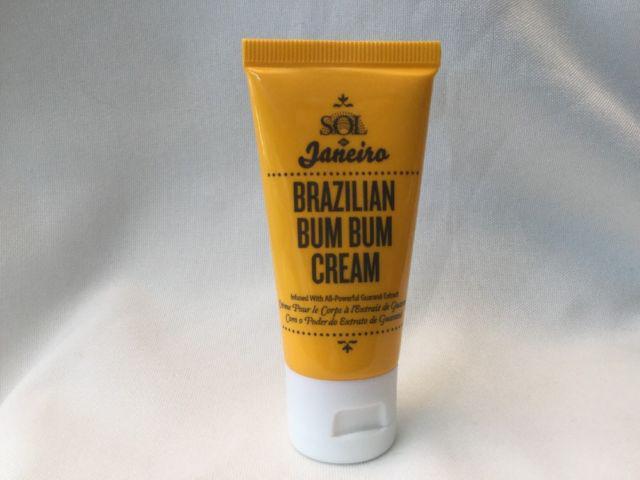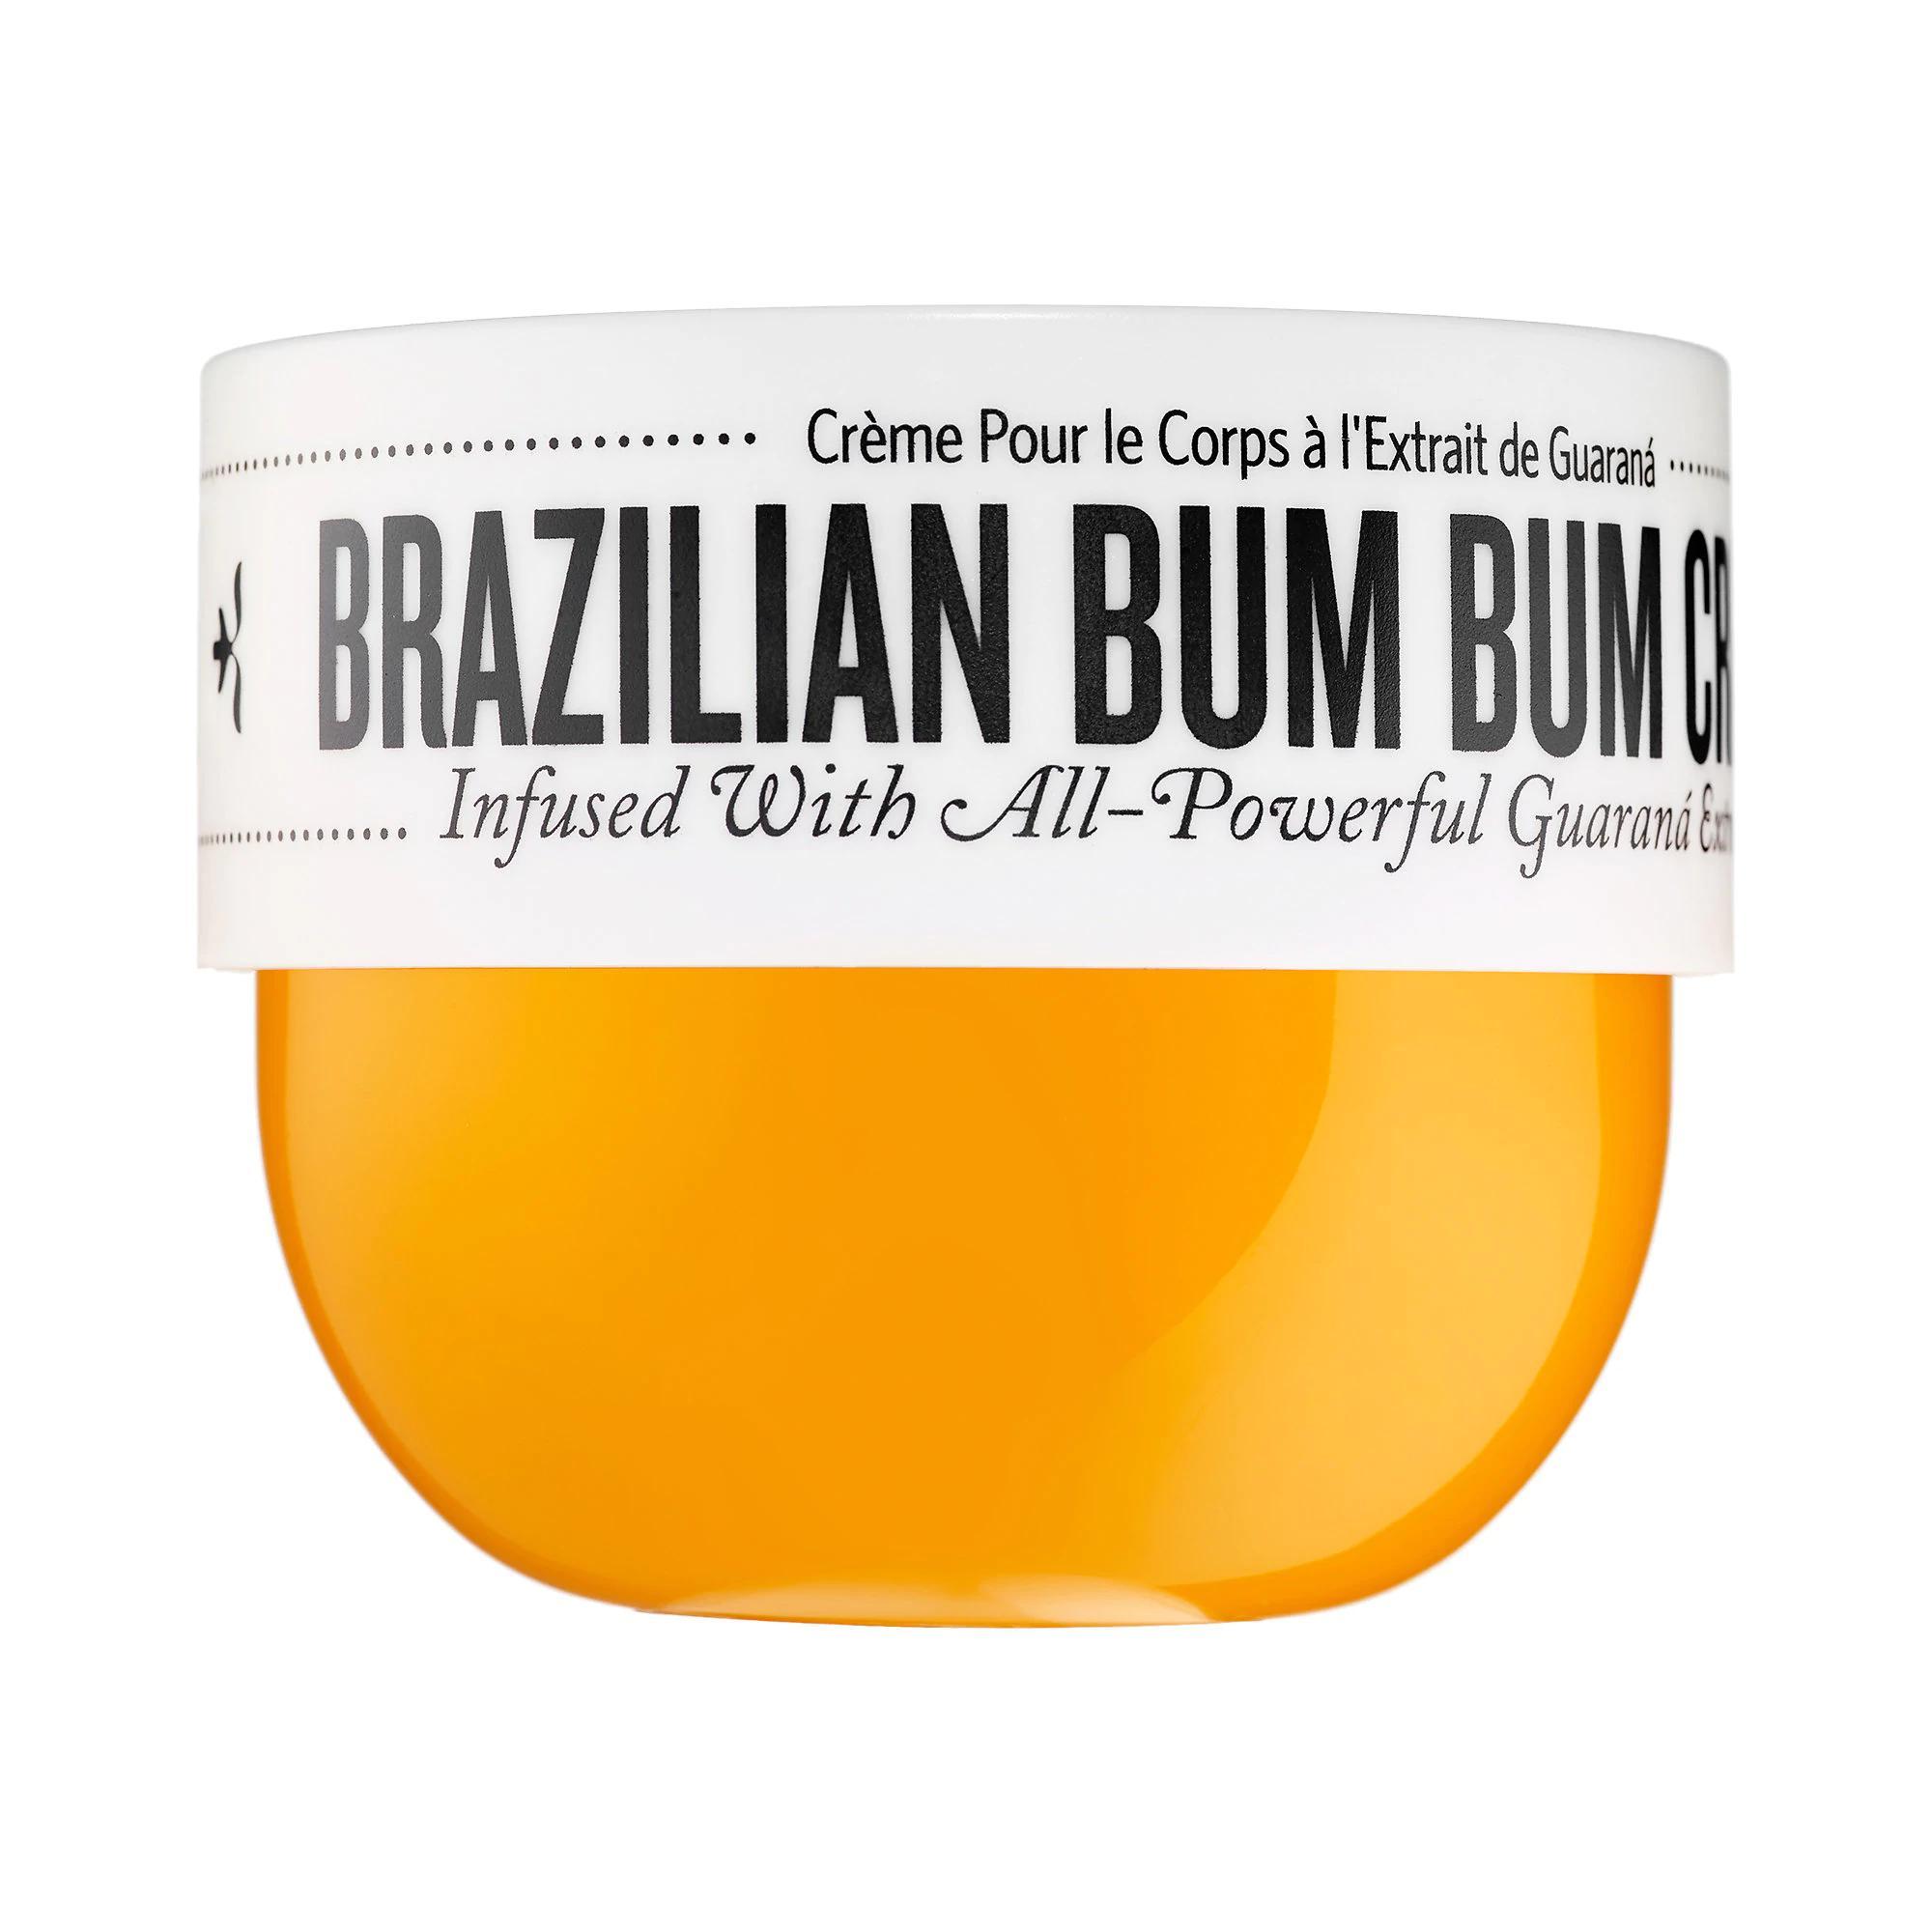The first image is the image on the left, the second image is the image on the right. Given the left and right images, does the statement "One of the images contains only a single orange squeeze tube with a white cap." hold true? Answer yes or no. Yes. The first image is the image on the left, the second image is the image on the right. For the images shown, is this caption "The left image contains one yellow tube with a flat white cap, and the right image includes a product with a yellow bowl-shaped bottom and a flat-topped white lid with black print around it." true? Answer yes or no. Yes. 